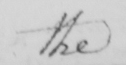Please provide the text content of this handwritten line. the 